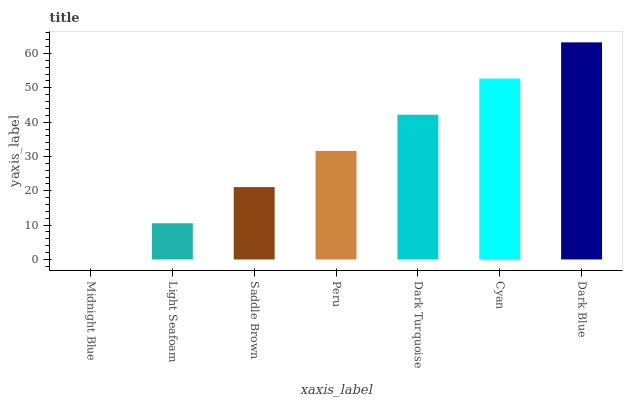Is Midnight Blue the minimum?
Answer yes or no. Yes. Is Dark Blue the maximum?
Answer yes or no. Yes. Is Light Seafoam the minimum?
Answer yes or no. No. Is Light Seafoam the maximum?
Answer yes or no. No. Is Light Seafoam greater than Midnight Blue?
Answer yes or no. Yes. Is Midnight Blue less than Light Seafoam?
Answer yes or no. Yes. Is Midnight Blue greater than Light Seafoam?
Answer yes or no. No. Is Light Seafoam less than Midnight Blue?
Answer yes or no. No. Is Peru the high median?
Answer yes or no. Yes. Is Peru the low median?
Answer yes or no. Yes. Is Cyan the high median?
Answer yes or no. No. Is Dark Turquoise the low median?
Answer yes or no. No. 